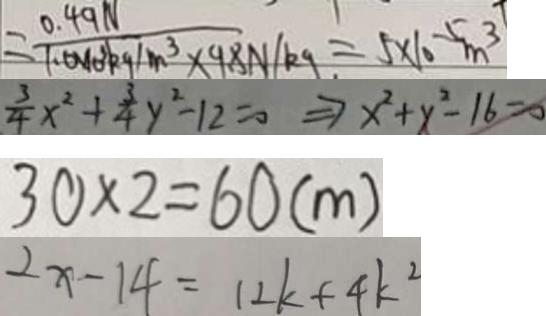<formula> <loc_0><loc_0><loc_500><loc_500>= \frac { 0 . 4 9 N } { 1 . 0 \times 1 0 ^ { 3 } k g / m ^ { 3 } \times 9 8 N / k g } = 5 \times 1 0 ^ { - 5 } m ^ { 3 } 
 \frac { 3 } { 4 } x ^ { 2 } + \frac { 3 } { 4 } y ^ { 2 } - 1 2 = 0 \Rightarrow x ^ { 2 } + y ^ { 2 } - 1 6 = 0 
 3 0 \times 2 = 6 0 ( m ) 
 2 x - 1 4 = 1 2 k + 4 k ^ { 2 }</formula> 